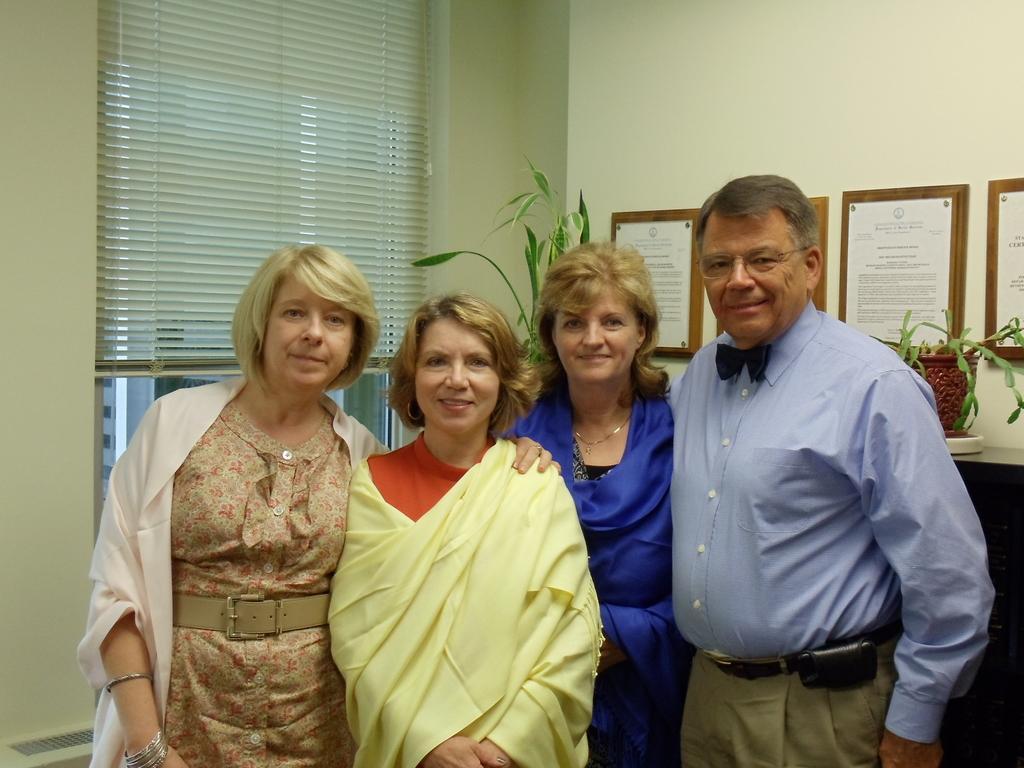Please provide a concise description of this image. There are three women and the man standing. These are the frames, which are attached to the wall. I can see two house plants placed on the table. This is the window. I think this is the window shutter curtains. 